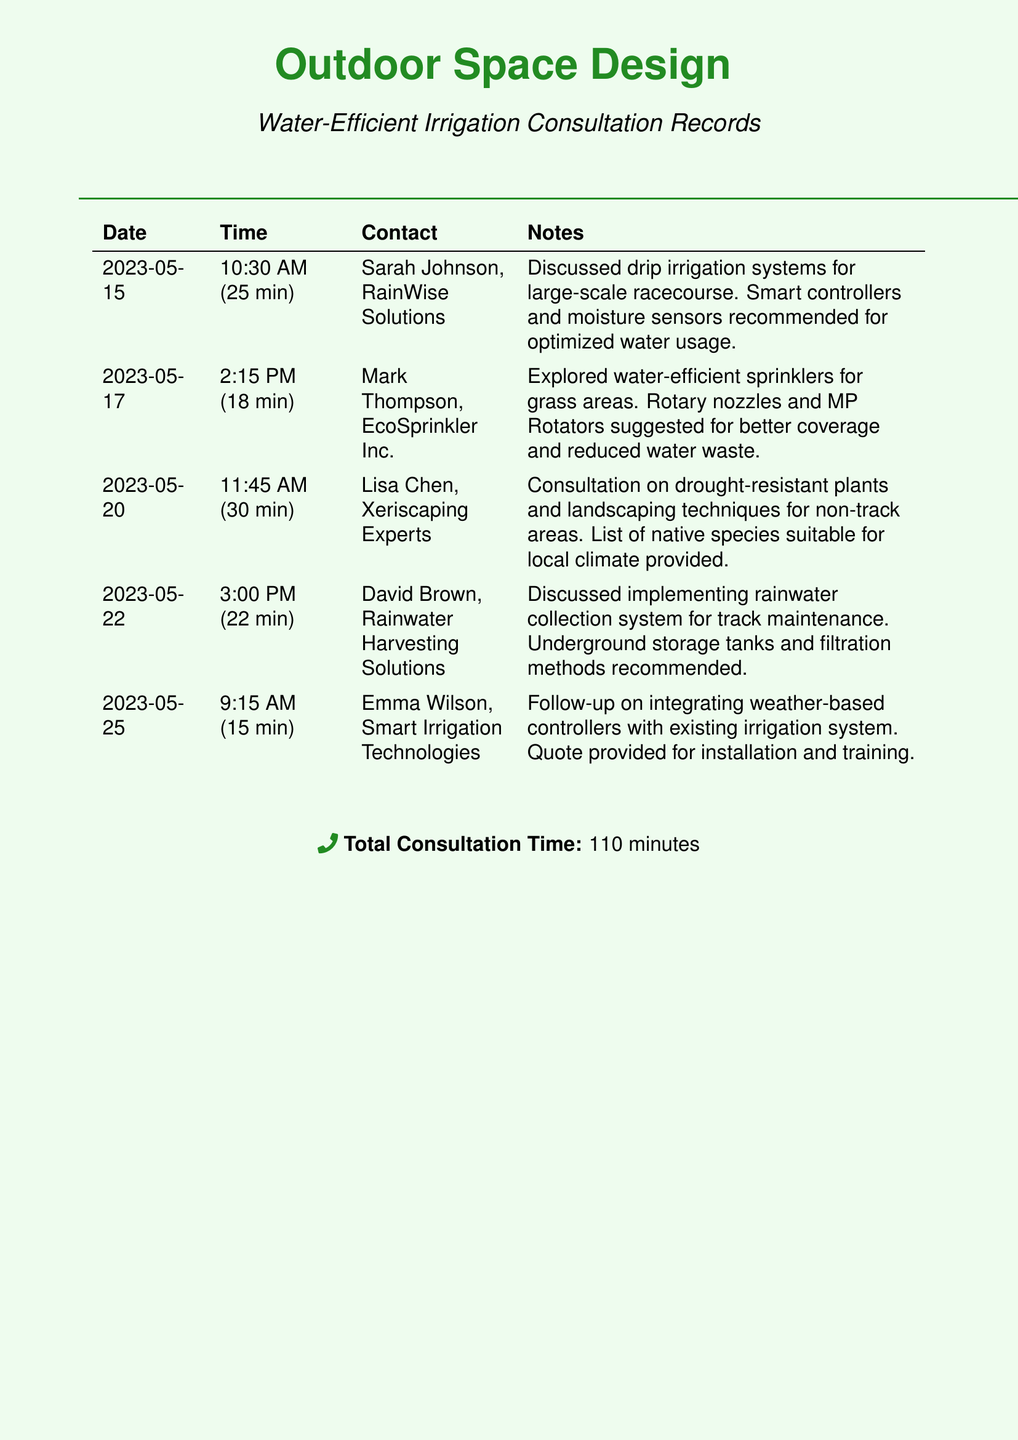What is the date of the first consultation? The date of the first consultation is the earliest entry in the document, which is 2023-05-15.
Answer: 2023-05-15 Who did the designer consult on drip irrigation systems? The designer consulted with Sarah Johnson from RainWise Solutions about drip irrigation systems.
Answer: Sarah Johnson, RainWise Solutions How long was the conversation with Mark Thompson? The length of the conversation with Mark Thompson is noted in the document as 18 minutes.
Answer: 18 min What system was discussed on May 22? The system discussed on May 22 was the rainwater collection system for track maintenance.
Answer: Rainwater collection system Which company provided a quote for installation and training? The company that provided a quote for installation and training is Smart Irrigation Technologies, represented by Emma Wilson.
Answer: Smart Irrigation Technologies How many total minutes were spent in consultations? The total consultation time is the sum of all conversation durations listed, which is 110 minutes.
Answer: 110 minutes What irrigation technology was recommended along with drip irrigation? The recommended technology along with drip irrigation was smart controllers and moisture sensors for optimized water usage.
Answer: Smart controllers and moisture sensors Which specialist discussed drought-resistant plants? The specialist who discussed drought-resistant plants is Lisa Chen from Xeriscaping Experts.
Answer: Lisa Chen, Xeriscaping Experts What type of nozzles did Mark Thompson suggest? Mark Thompson suggested rotary nozzles and MP Rotators for better coverage and reduced water waste.
Answer: Rotary nozzles and MP Rotators What are the recommended methods for rainwater collection? The recommended methods for rainwater collection include underground storage tanks and filtration methods.
Answer: Underground storage tanks and filtration methods 